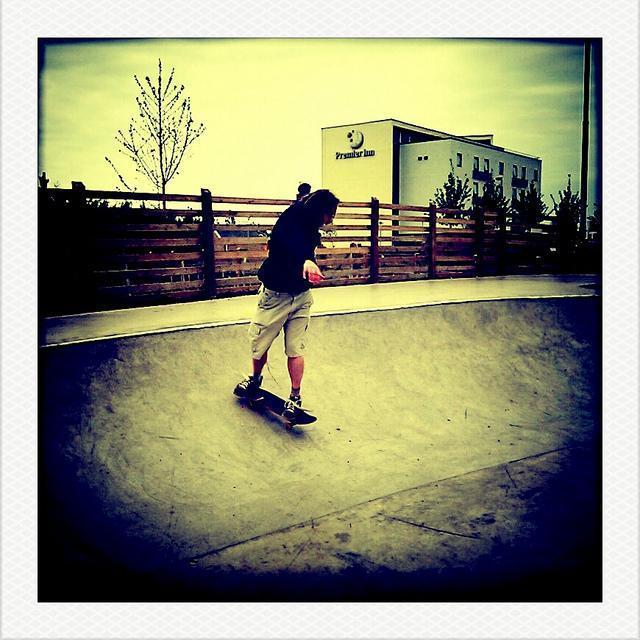How many trees are in this photo?
Give a very brief answer. 5. How many books are in the image?
Give a very brief answer. 0. 